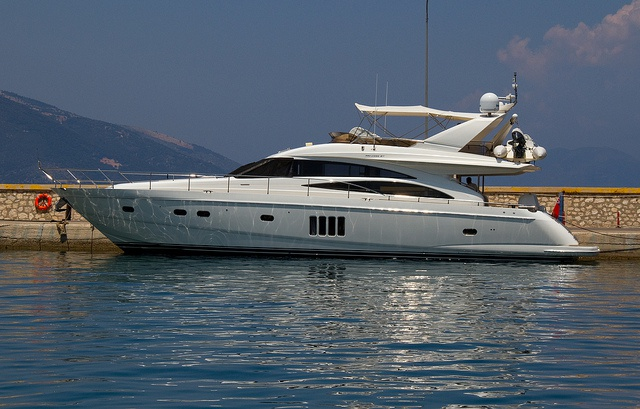Describe the objects in this image and their specific colors. I can see boat in gray, black, darkgray, and lightgray tones and people in black and gray tones in this image. 